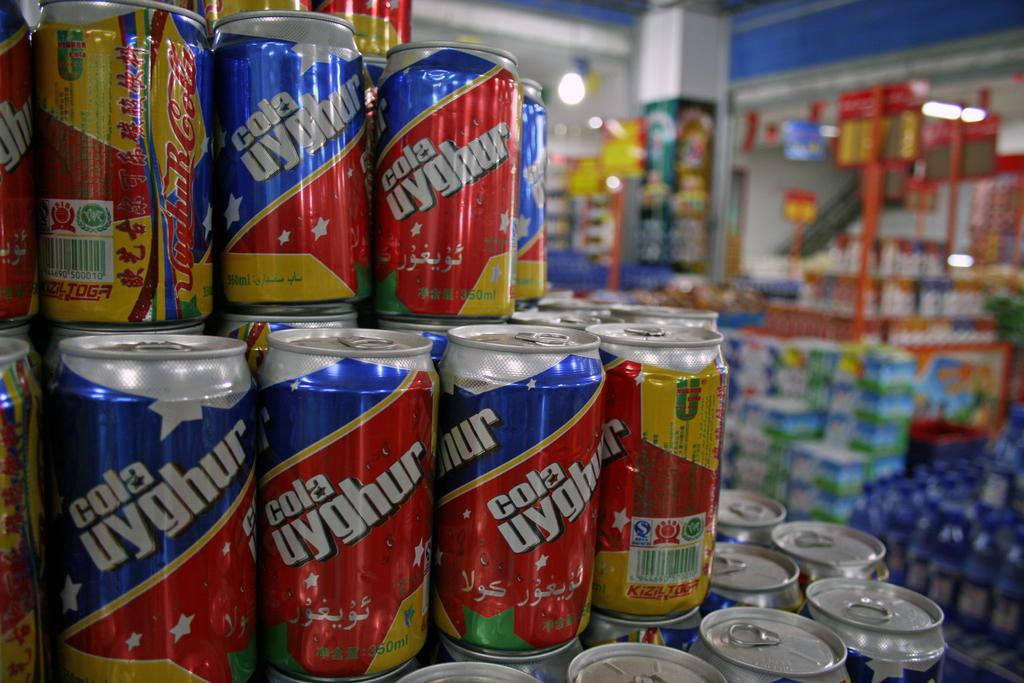<image>
Create a compact narrative representing the image presented.  cola uyghur cans displayed close up for sale at a store. 